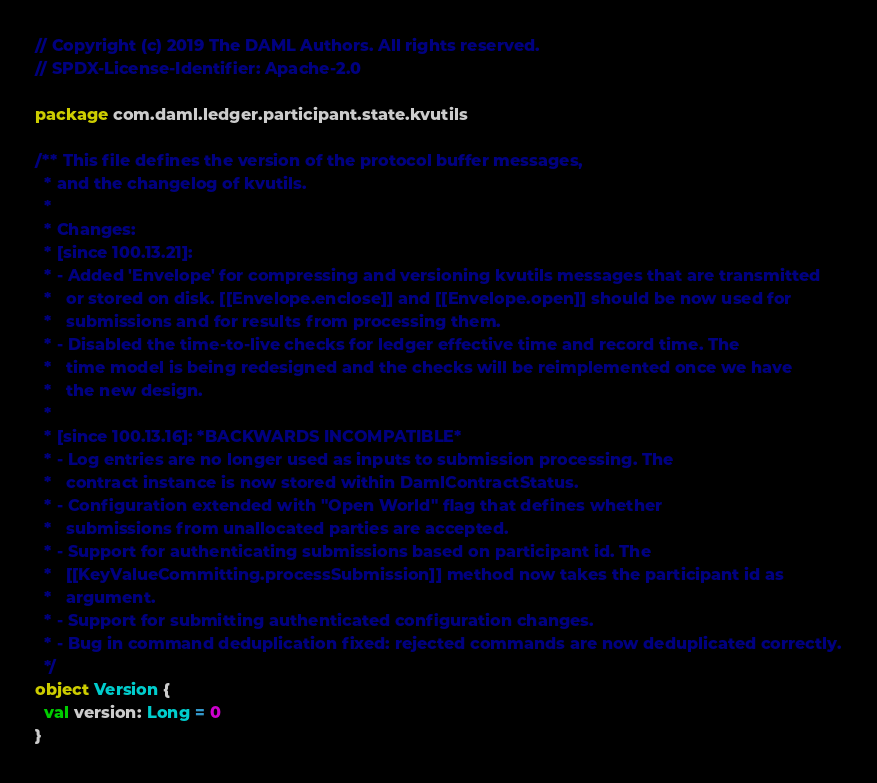Convert code to text. <code><loc_0><loc_0><loc_500><loc_500><_Scala_>// Copyright (c) 2019 The DAML Authors. All rights reserved.
// SPDX-License-Identifier: Apache-2.0

package com.daml.ledger.participant.state.kvutils

/** This file defines the version of the protocol buffer messages,
  * and the changelog of kvutils.
  *
  * Changes:
  * [since 100.13.21]:
  * - Added 'Envelope' for compressing and versioning kvutils messages that are transmitted
  *   or stored on disk. [[Envelope.enclose]] and [[Envelope.open]] should be now used for
  *   submissions and for results from processing them.
  * - Disabled the time-to-live checks for ledger effective time and record time. The
  *   time model is being redesigned and the checks will be reimplemented once we have
  *   the new design.
  *
  * [since 100.13.16]: *BACKWARDS INCOMPATIBLE*
  * - Log entries are no longer used as inputs to submission processing. The
  *   contract instance is now stored within DamlContractStatus.
  * - Configuration extended with "Open World" flag that defines whether
  *   submissions from unallocated parties are accepted.
  * - Support for authenticating submissions based on participant id. The
  *   [[KeyValueCommitting.processSubmission]] method now takes the participant id as
  *   argument.
  * - Support for submitting authenticated configuration changes.
  * - Bug in command deduplication fixed: rejected commands are now deduplicated correctly.
  */
object Version {
  val version: Long = 0
}
</code> 